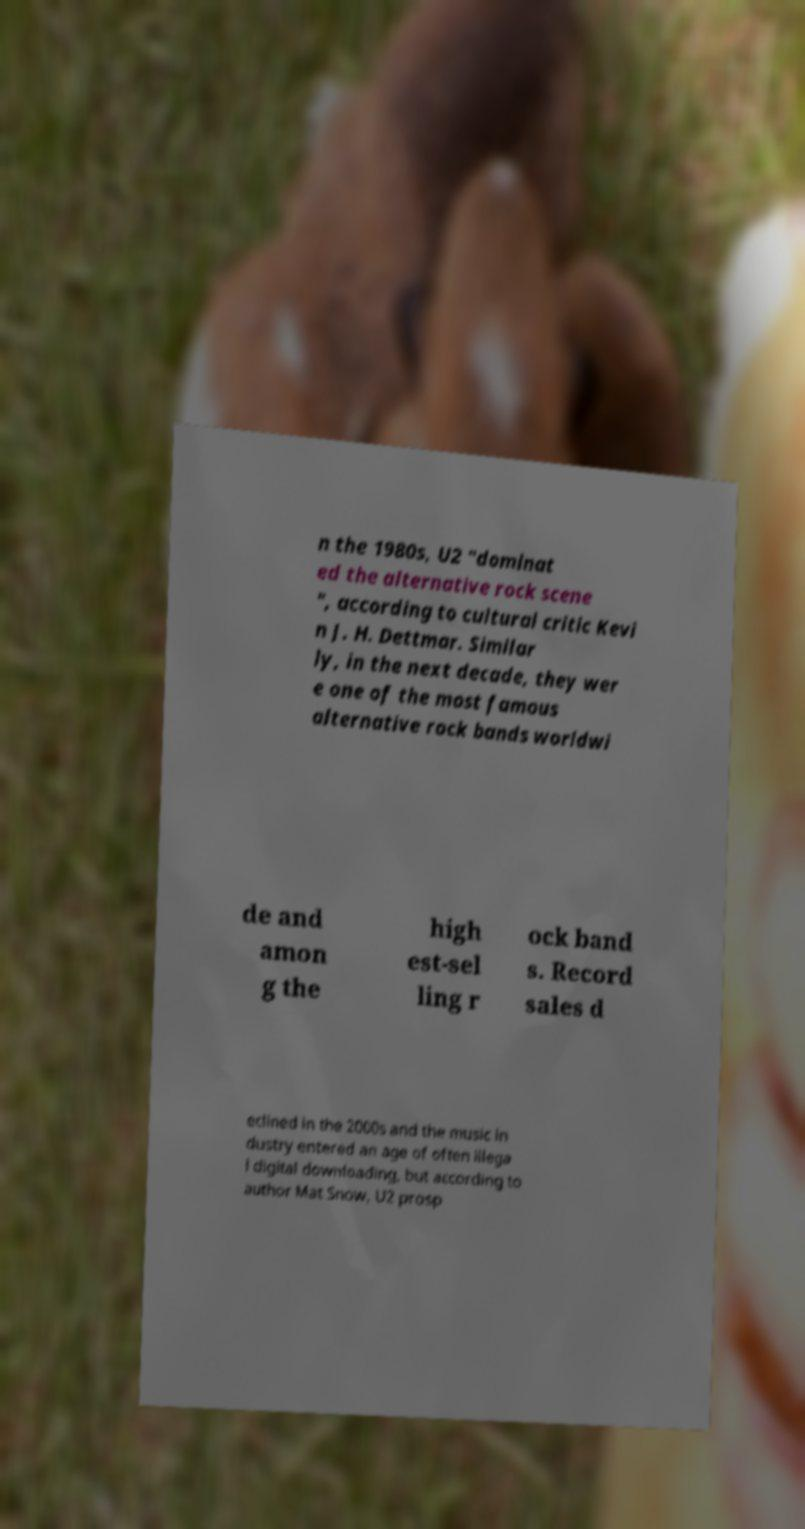There's text embedded in this image that I need extracted. Can you transcribe it verbatim? n the 1980s, U2 "dominat ed the alternative rock scene ", according to cultural critic Kevi n J. H. Dettmar. Similar ly, in the next decade, they wer e one of the most famous alternative rock bands worldwi de and amon g the high est-sel ling r ock band s. Record sales d eclined in the 2000s and the music in dustry entered an age of often illega l digital downloading, but according to author Mat Snow, U2 prosp 